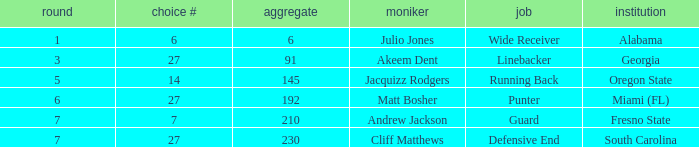Which overall's pick number was 14? 145.0. 